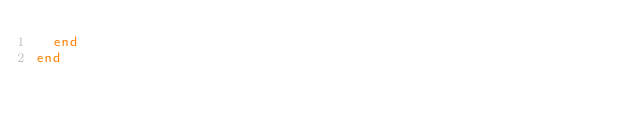Convert code to text. <code><loc_0><loc_0><loc_500><loc_500><_Ruby_>  end
end
</code> 